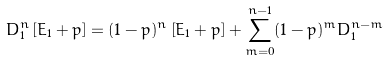<formula> <loc_0><loc_0><loc_500><loc_500>D _ { 1 } ^ { n } \left [ E _ { 1 } + p \right ] = ( 1 - p ) ^ { n } \left [ E _ { 1 } + p \right ] + \sum _ { m = 0 } ^ { n - 1 } ( 1 - p ) ^ { m } D _ { 1 } ^ { n - m }</formula> 